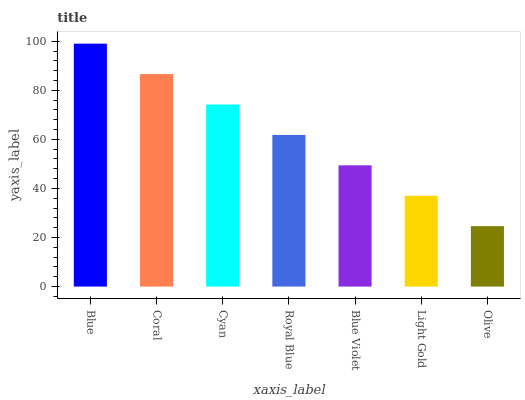Is Olive the minimum?
Answer yes or no. Yes. Is Blue the maximum?
Answer yes or no. Yes. Is Coral the minimum?
Answer yes or no. No. Is Coral the maximum?
Answer yes or no. No. Is Blue greater than Coral?
Answer yes or no. Yes. Is Coral less than Blue?
Answer yes or no. Yes. Is Coral greater than Blue?
Answer yes or no. No. Is Blue less than Coral?
Answer yes or no. No. Is Royal Blue the high median?
Answer yes or no. Yes. Is Royal Blue the low median?
Answer yes or no. Yes. Is Light Gold the high median?
Answer yes or no. No. Is Cyan the low median?
Answer yes or no. No. 